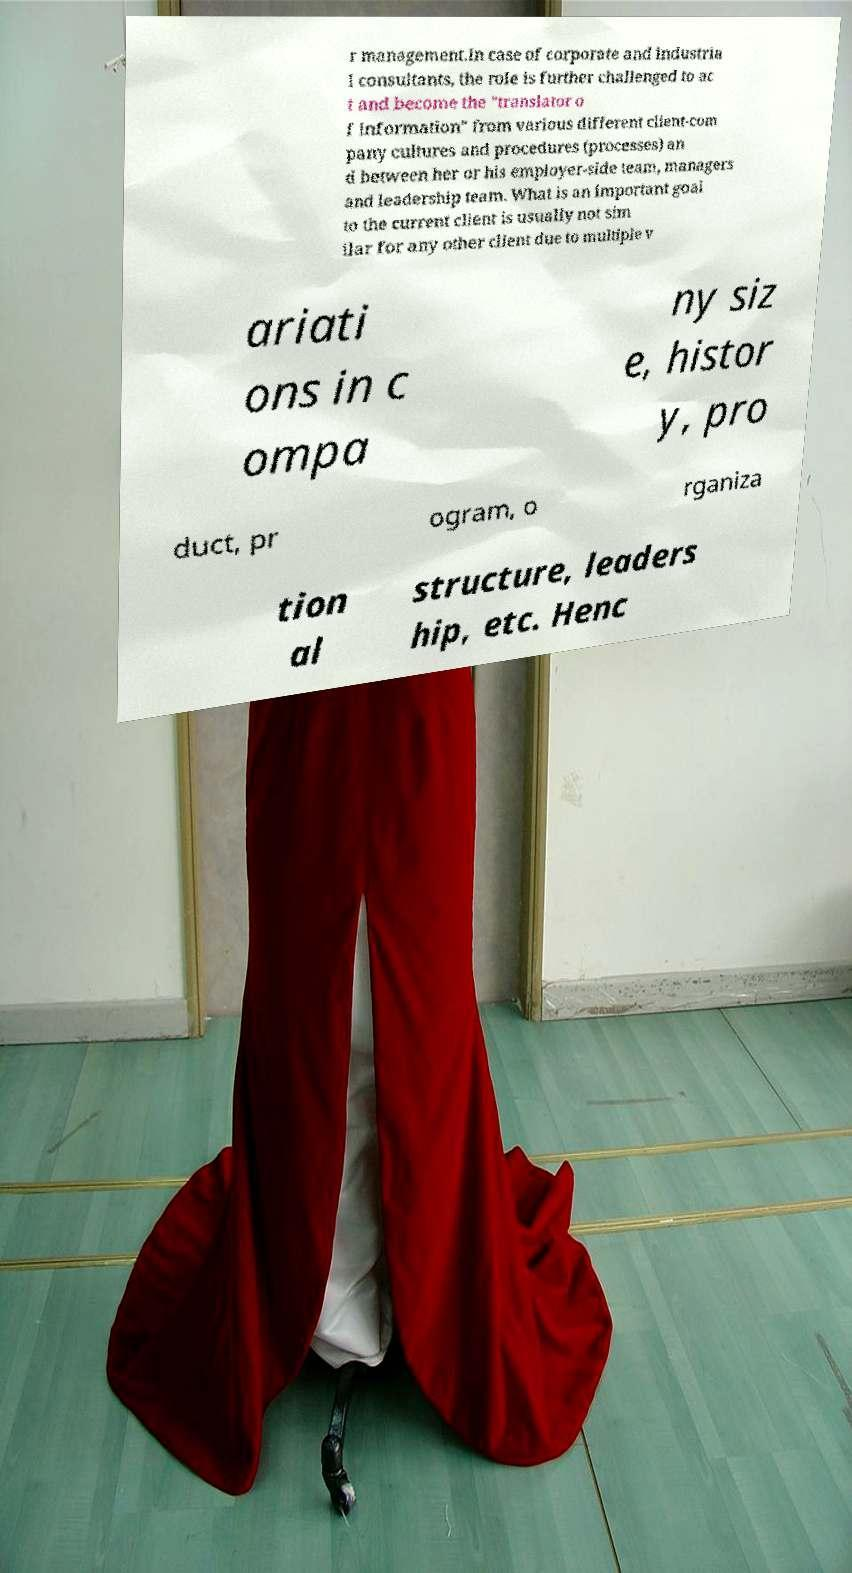Could you assist in decoding the text presented in this image and type it out clearly? r management.In case of corporate and industria l consultants, the role is further challenged to ac t and become the "translator o f information" from various different client-com pany cultures and procedures (processes) an d between her or his employer-side team, managers and leadership team. What is an important goal to the current client is usually not sim ilar for any other client due to multiple v ariati ons in c ompa ny siz e, histor y, pro duct, pr ogram, o rganiza tion al structure, leaders hip, etc. Henc 